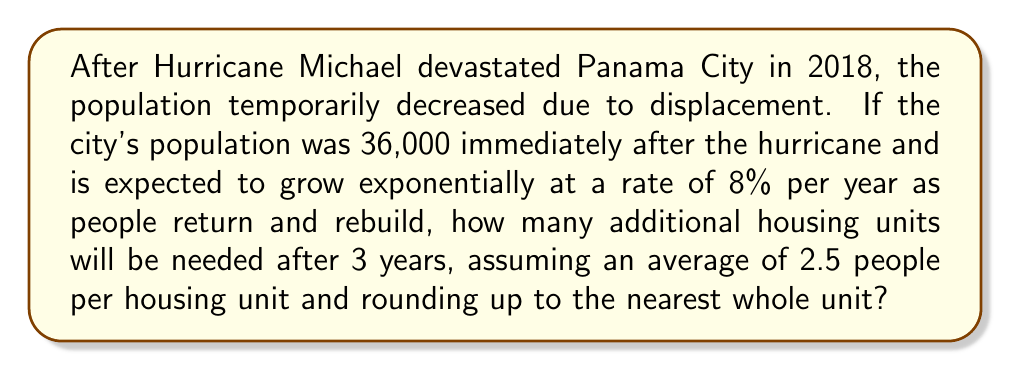Could you help me with this problem? Let's approach this step-by-step:

1) The exponential growth formula is:
   $A = P(1 + r)^t$
   Where:
   $A$ = Final amount
   $P$ = Initial principal balance
   $r$ = Growth rate (as a decimal)
   $t$ = Time in years

2) We have:
   $P = 36,000$ (initial population)
   $r = 0.08$ (8% growth rate)
   $t = 3$ years

3) Let's calculate the population after 3 years:
   $A = 36,000(1 + 0.08)^3$
   $A = 36,000(1.08)^3$
   $A = 36,000(1.259712)$
   $A = 45,349.632$

4) The population increase is:
   $45,349.632 - 36,000 = 9,349.632$

5) To find the number of housing units, divide by 2.5 people per unit:
   $9,349.632 \div 2.5 = 3,739.8528$

6) Rounding up to the nearest whole unit:
   $3,739.8528 \approx 3,740$ units
Answer: 3,740 housing units 